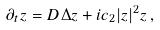Convert formula to latex. <formula><loc_0><loc_0><loc_500><loc_500>\partial _ { t } z = D \Delta z + i c _ { 2 } | z | ^ { 2 } z \, ,</formula> 